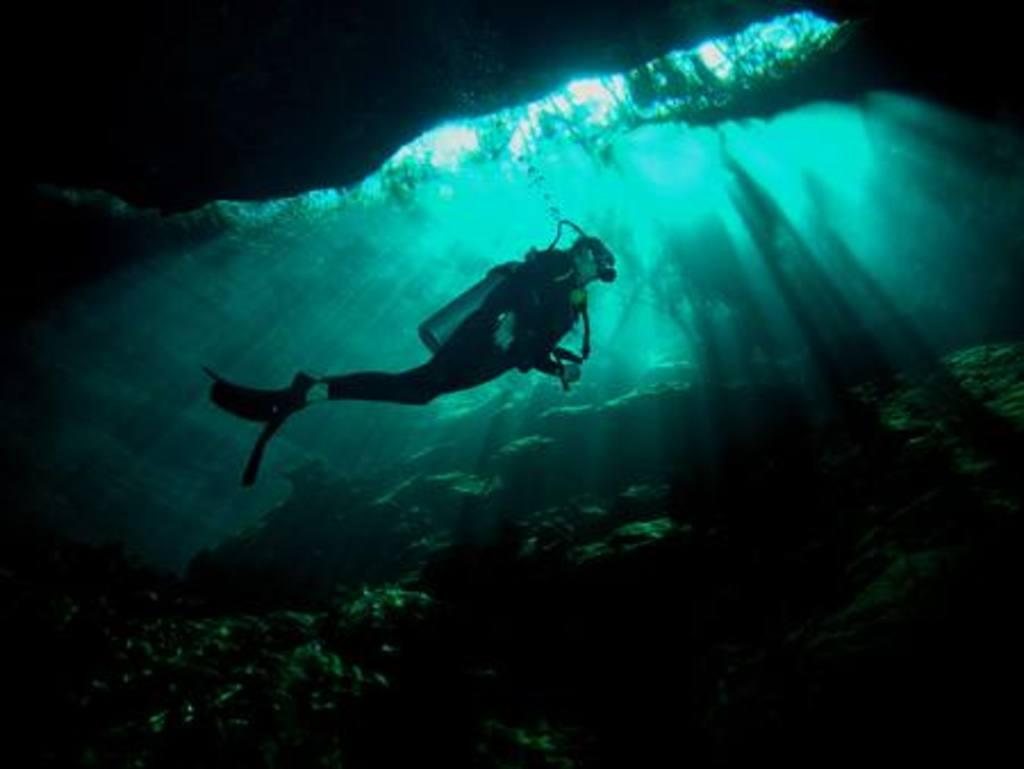What is the person in the image doing? The person is swimming in the image. What type of clothing is the person wearing? The person is wearing a swimsuit. What additional equipment is the person using while swimming? The person is wearing an oxygen mask. What can be seen at the bottom of the image? There are stones visible at the bottom of the image. What type of vacation is the minister planning based on the image? There is no minister or vacation mentioned or depicted in the image. 